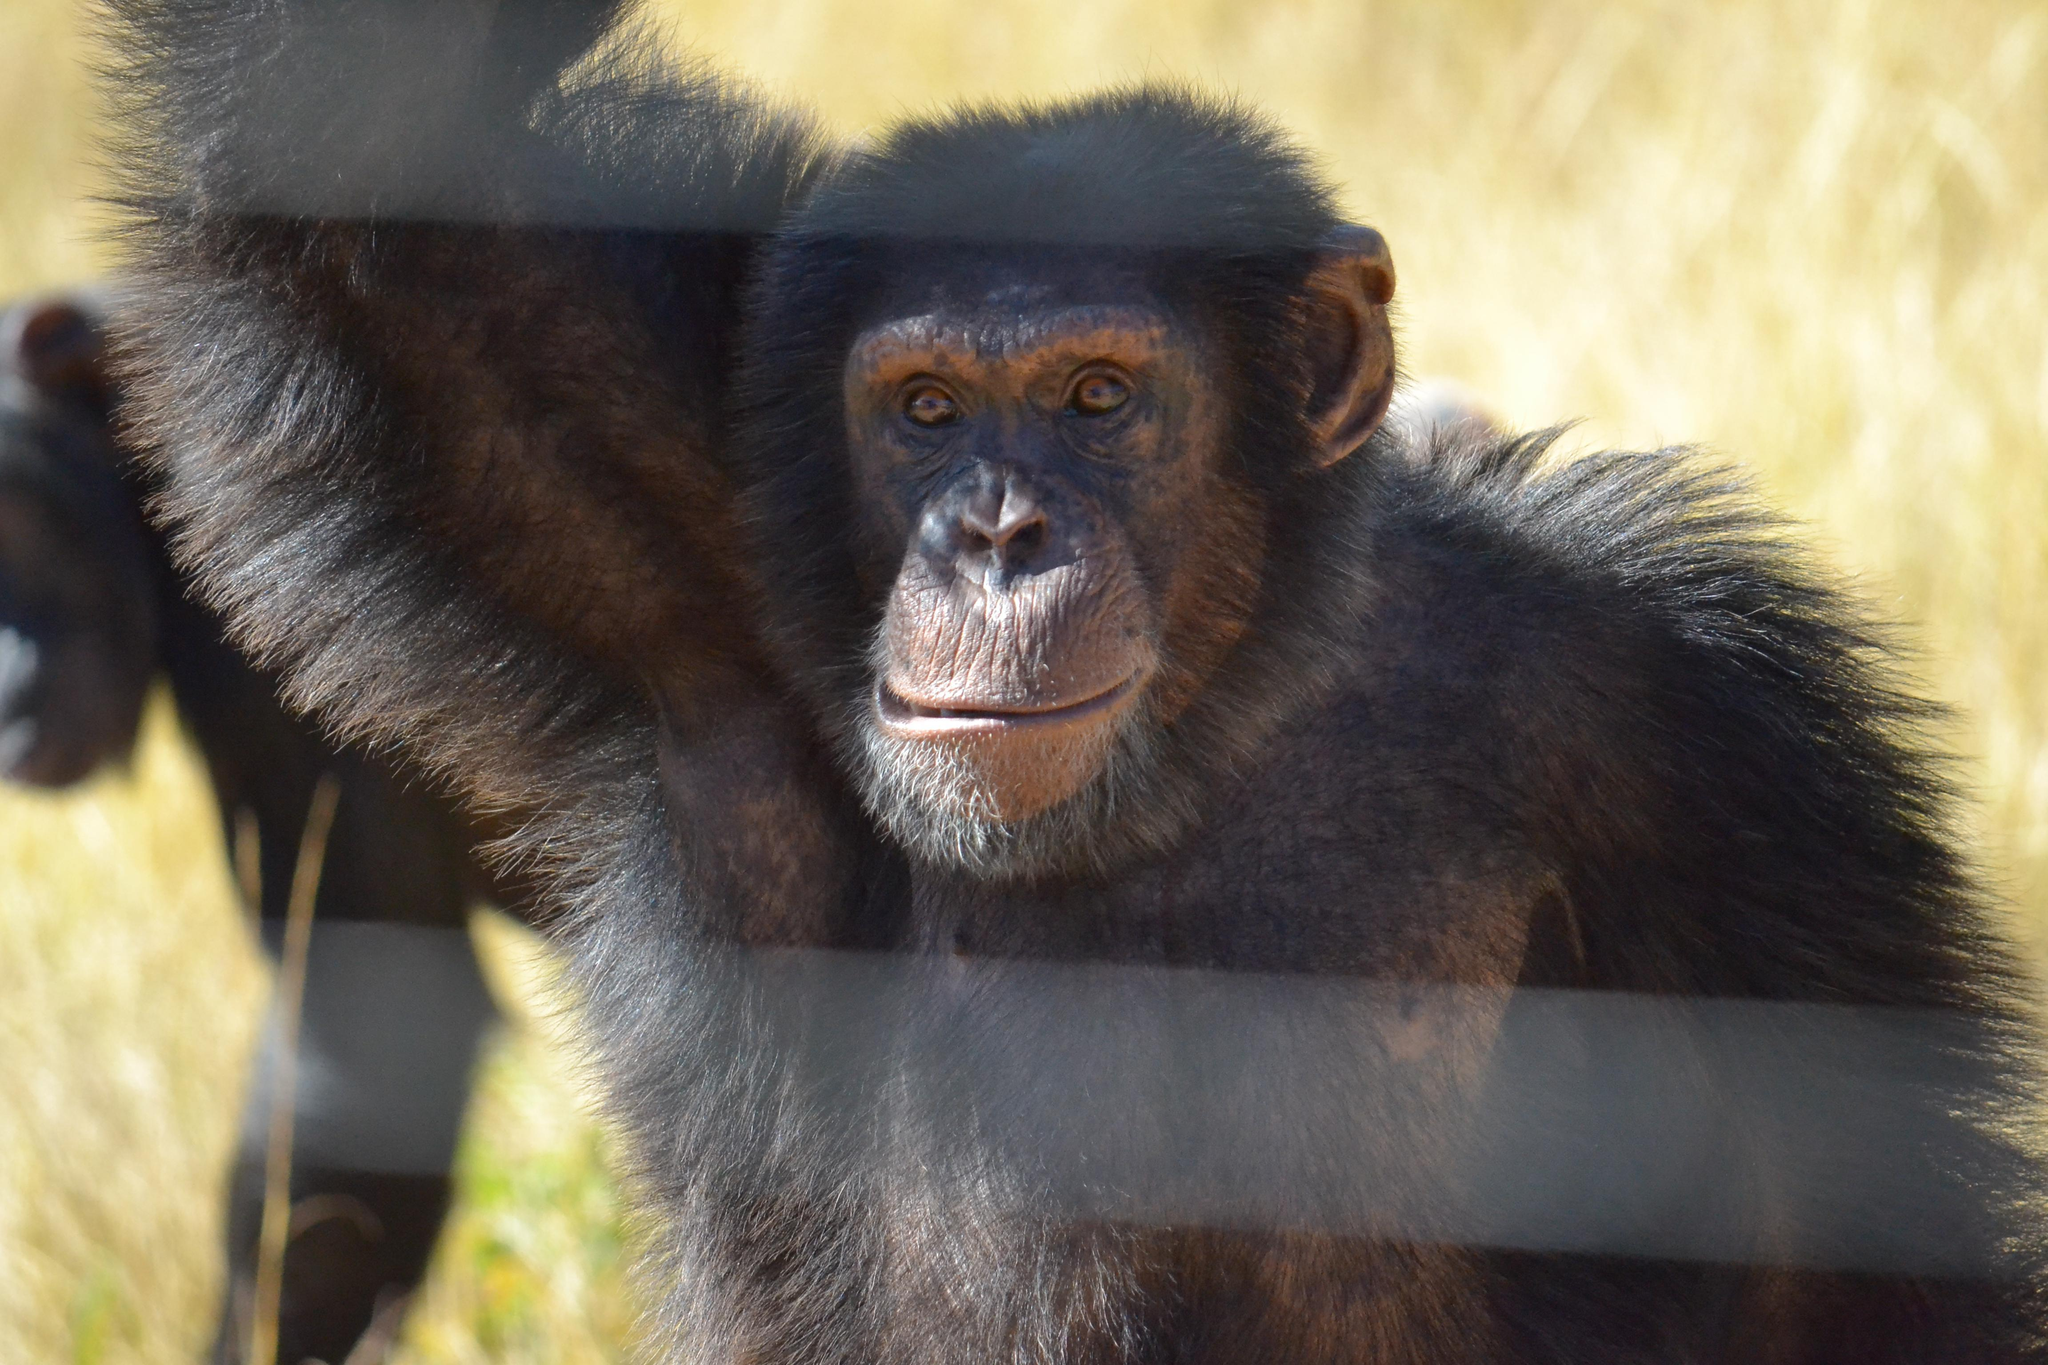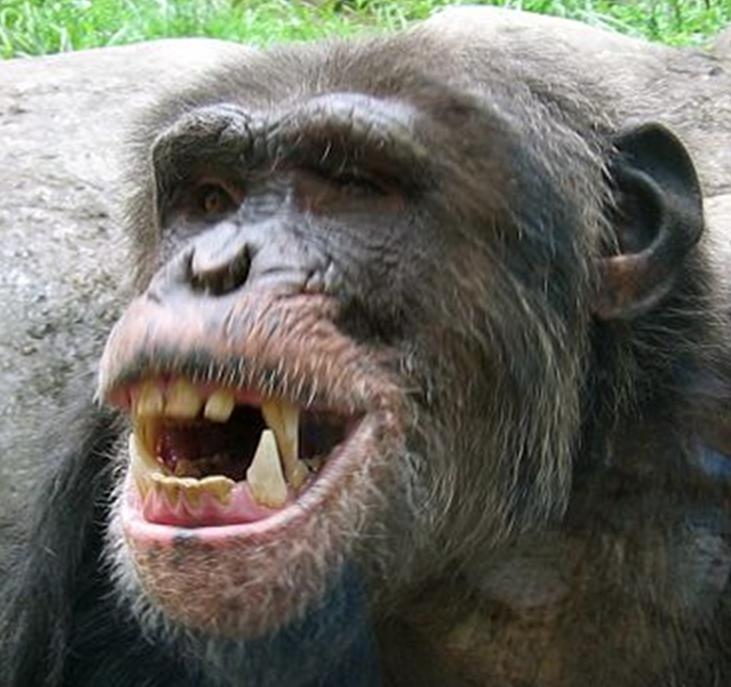The first image is the image on the left, the second image is the image on the right. Analyze the images presented: Is the assertion "One image includes two apes sitting directly face to face, while the other image features chimps sitting one behind the other." valid? Answer yes or no. No. The first image is the image on the left, the second image is the image on the right. For the images shown, is this caption "There is exactly three chimpanzees in the right image." true? Answer yes or no. No. 